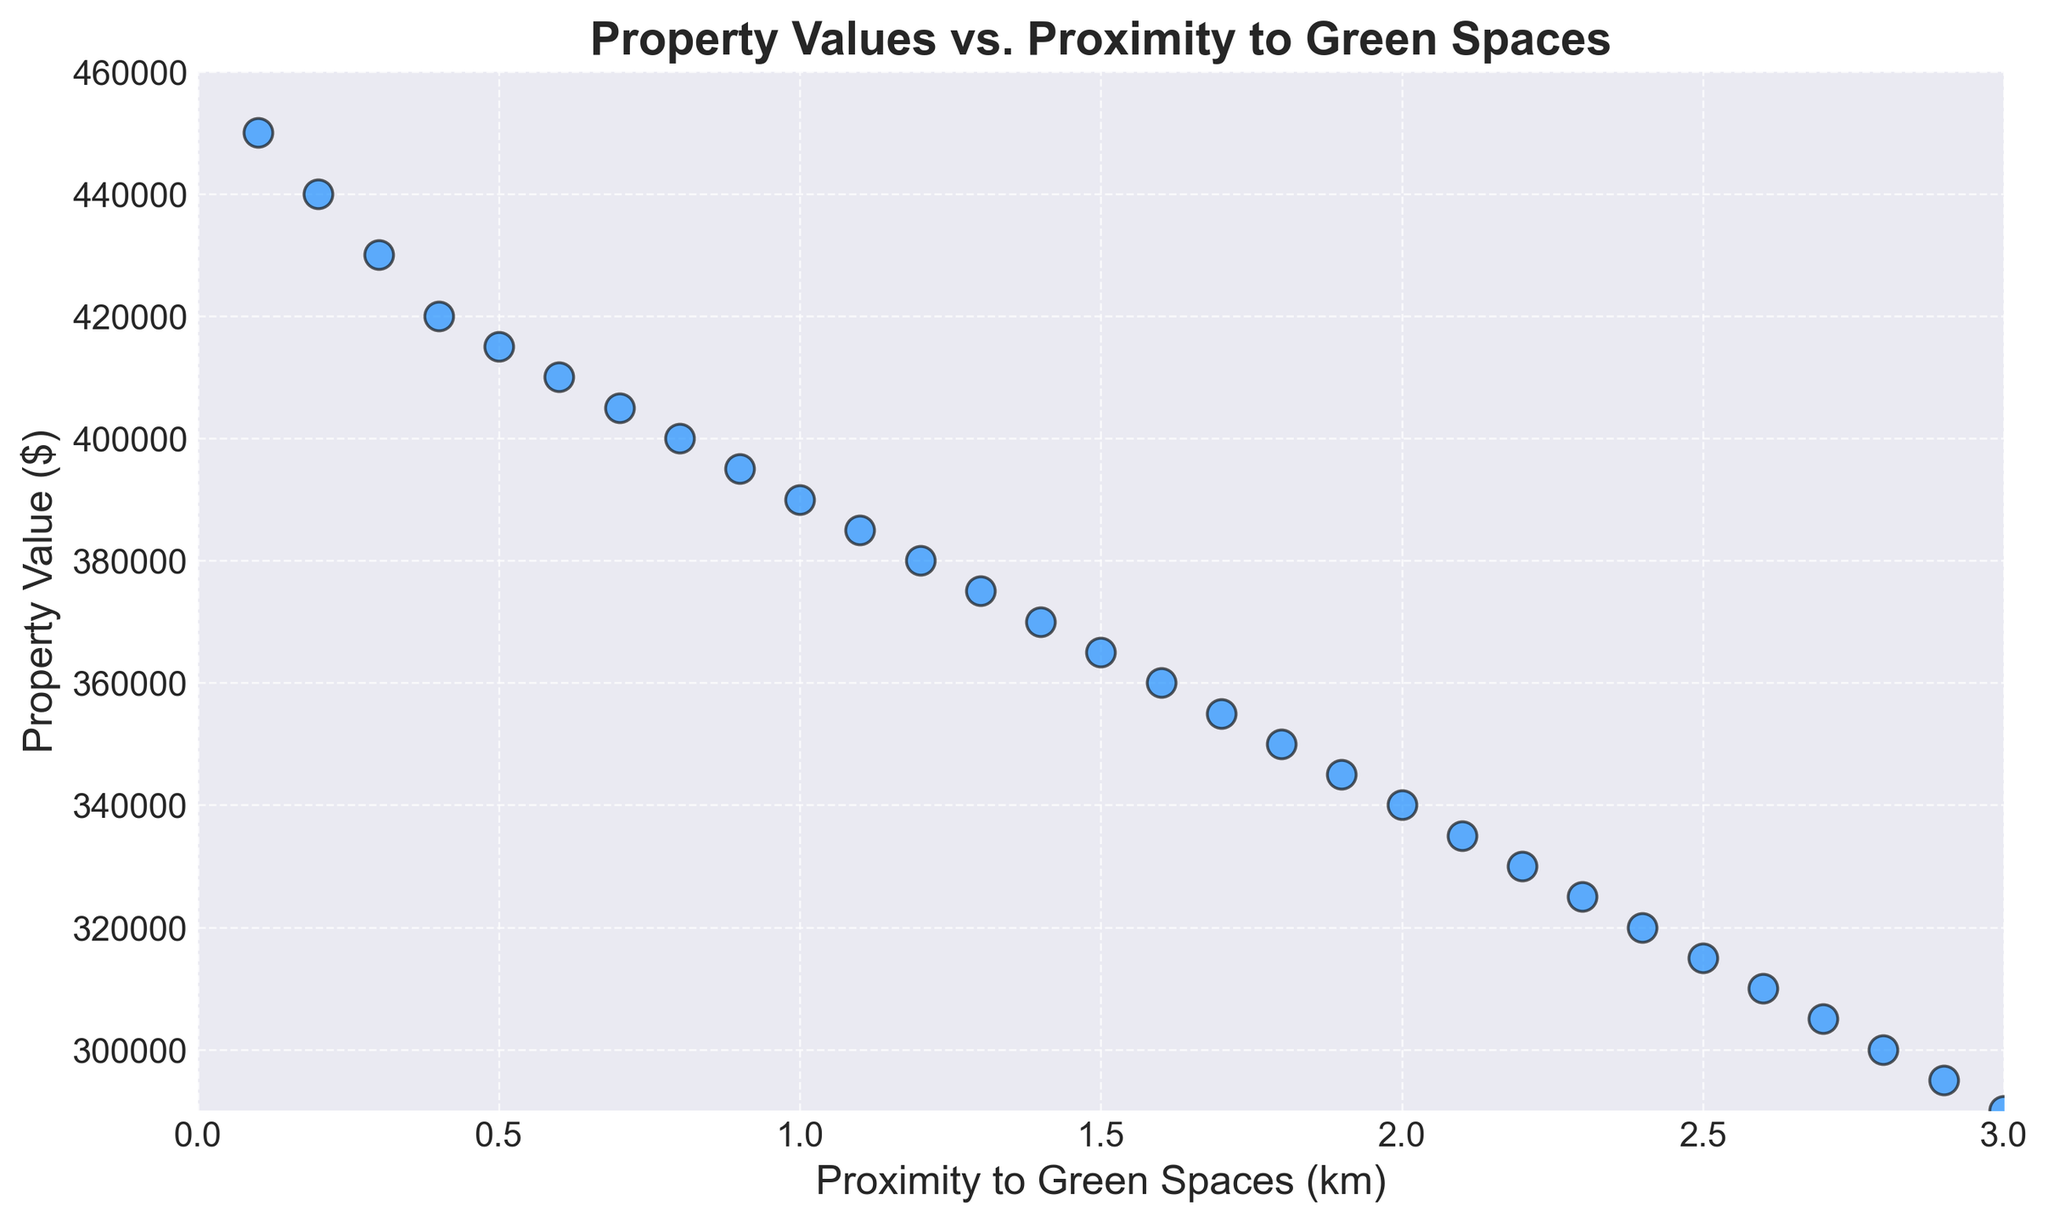What's the property value at the closest proximity to green spaces? Locate the point on the scatter plot with the smallest proximity value (0.1 km) and examine its corresponding property value, which is 450,000 dollars.
Answer: 450,000 dollars What is the difference in property value between locations at 0.5 km and 2.0 km proximity to green spaces? Identify the property values at 0.5 km (415,000 dollars) and 2.0 km (340,000 dollars), then subtract the latter from the former: 415,000 - 340,000 = 75,000 dollars.
Answer: 75,000 dollars What is the trend observed as proximity to green spaces increases? Examining the scatter plot reveals that property values consistently decrease as proximity to green spaces increases, indicating a negative trend.
Answer: Property values decrease Which proximity has a property value of 380,000 dollars? Locate the data point where the property value is 380,000 dollars, which corresponds to a proximity of 1.2 km.
Answer: 1.2 km Compare the property values at 1.0 km and 3.0 km proximity to green spaces. Which is higher and by how much? Identify the property values at 1.0 km (390,000 dollars) and 3.0 km (290,000 dollars). Subtract the latter from the former: 390,000 - 290,000 = 100,000 dollars. The value at 1.0 km is higher by 100,000 dollars.
Answer: 1.0 km is higher by 100,000 dollars What is the average property value for proximity distances of 1.0 km and 2.0 km? Add the property values at 1.0 km (390,000 dollars) and 2.0 km (340,000 dollars) and divide by 2. (390,000 + 340,000) / 2 = 365,000 dollars.
Answer: 365,000 dollars What is the relationship between property value and proximity to green spaces? Examine the overall pattern in the scatter plot; it shows that as proximity to green spaces increases, property values decrease, indicating a negative correlation.
Answer: Negative correlation Are property values within 0.1 km to 1.0 km of green spaces higher than those within 2.1 km to 3.0 km? Compare the property values for proximities 0.1 to 1.0 km (range: 450,000 to 390,000 dollars) with those for 2.1 to 3.0 km (range: 335,000 to 290,000 dollars). The values in the 0.1 to 1.0 km range are higher.
Answer: Yes How much higher is the property value at 0.1 km compared to the lowest value on the plot? Identify the highest value at 0.1 km (450,000 dollars) and the lowest value, which is at 3.0 km (290,000 dollars). Subtract the latter from the former: 450,000 - 290,000 = 160,000 dollars.
Answer: 160,000 dollars At what proximity does the property value reach 365,000 dollars? Locate the data point where the property value is 365,000 dollars; this corresponds to a proximity of 1.5 km.
Answer: 1.5 km 